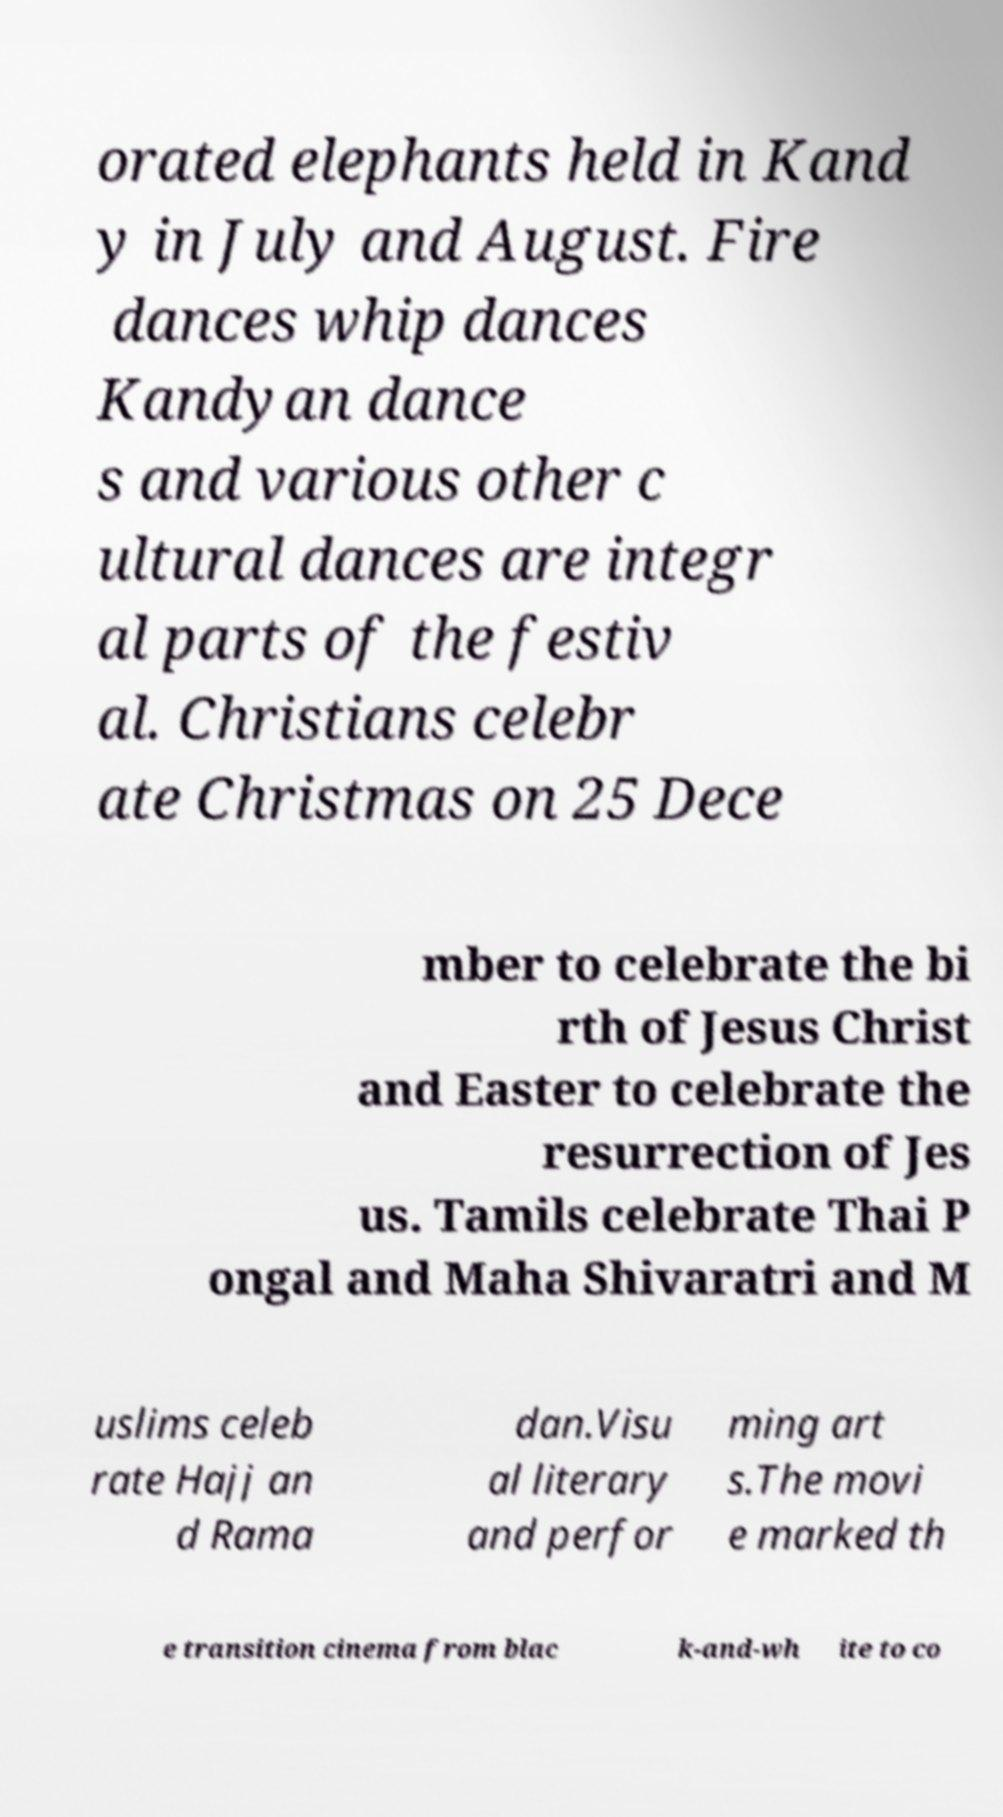Could you assist in decoding the text presented in this image and type it out clearly? orated elephants held in Kand y in July and August. Fire dances whip dances Kandyan dance s and various other c ultural dances are integr al parts of the festiv al. Christians celebr ate Christmas on 25 Dece mber to celebrate the bi rth of Jesus Christ and Easter to celebrate the resurrection of Jes us. Tamils celebrate Thai P ongal and Maha Shivaratri and M uslims celeb rate Hajj an d Rama dan.Visu al literary and perfor ming art s.The movi e marked th e transition cinema from blac k-and-wh ite to co 